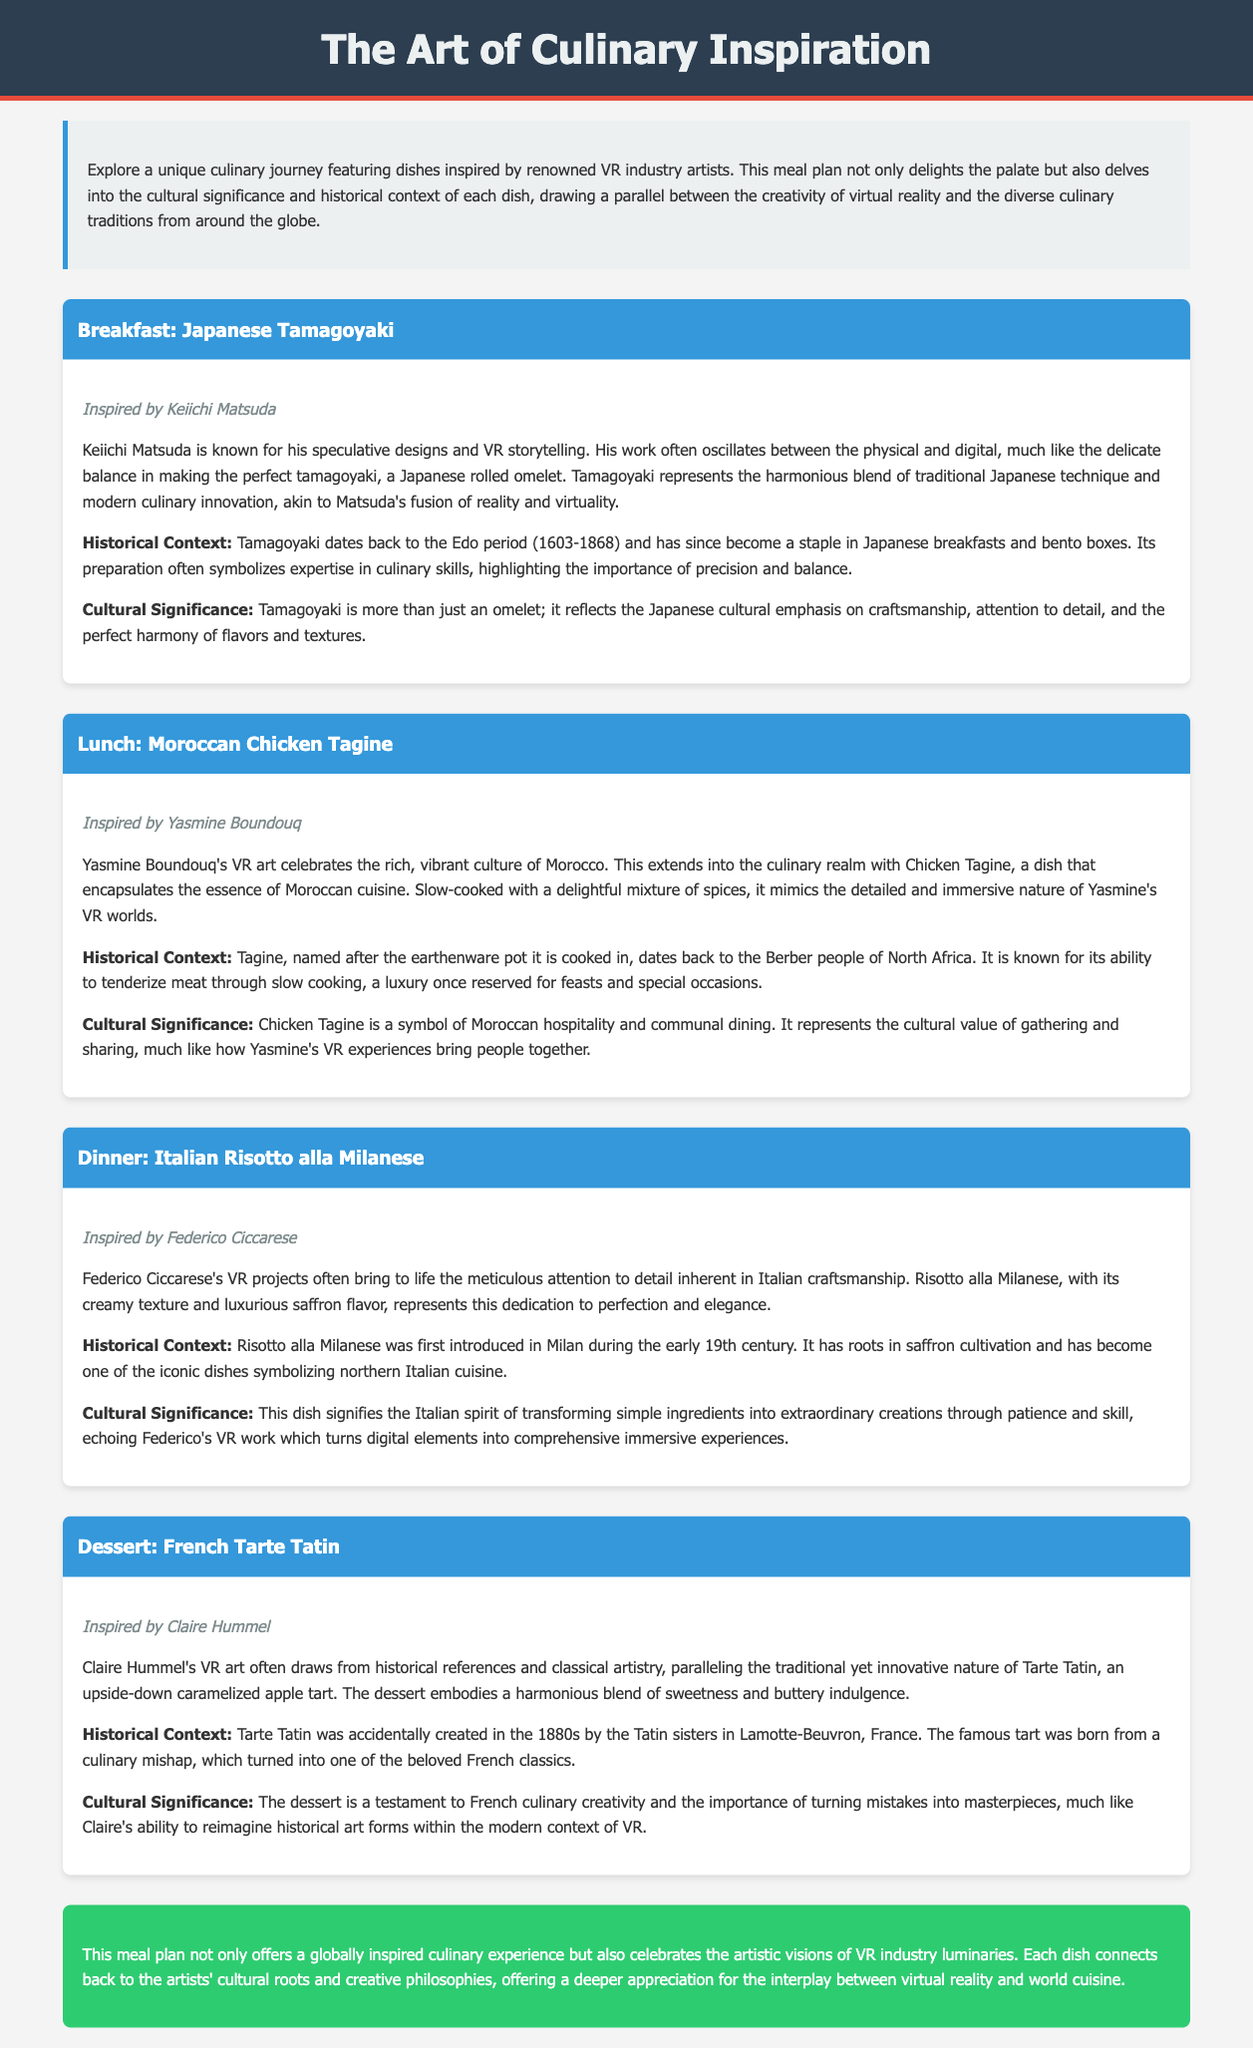What is the first dish in the meal plan? The first dish in the meal plan is mentioned in the Breakfast section, which is Japanese Tamagoyaki.
Answer: Japanese Tamagoyaki Who is the artist inspiring the Lunch dish? The Lunch dish, Moroccan Chicken Tagine, is inspired by Yasmine Boundouq.
Answer: Yasmine Boundouq What period does the historical context of Tamagoyaki refer to? The historical context of Tamagoyaki mentions the Edo period, which lasted from 1603-1868.
Answer: Edo period (1603-1868) What cultural value is symbolized by Chicken Tagine? The cultural value symbolized by Chicken Tagine is Moroccan hospitality and communal dining.
Answer: Moroccan hospitality When was Tarte Tatin accidentally created? Tarte Tatin was accidentally created in the 1880s.
Answer: 1880s Which dish represents the Italian spirit of transforming simple ingredients? The dish that represents this spirit is Risotto alla Milanese.
Answer: Risotto alla Milanese What is the theme of the meal plan? The theme of the meal plan is to explore culinary dishes inspired by artists in the VR industry.
Answer: Culinary dishes inspired by artists in the VR industry What type of meal is Risotto alla Milanese categorized as? Risotto alla Milanese is categorized as Dinner in the meal plan.
Answer: Dinner 